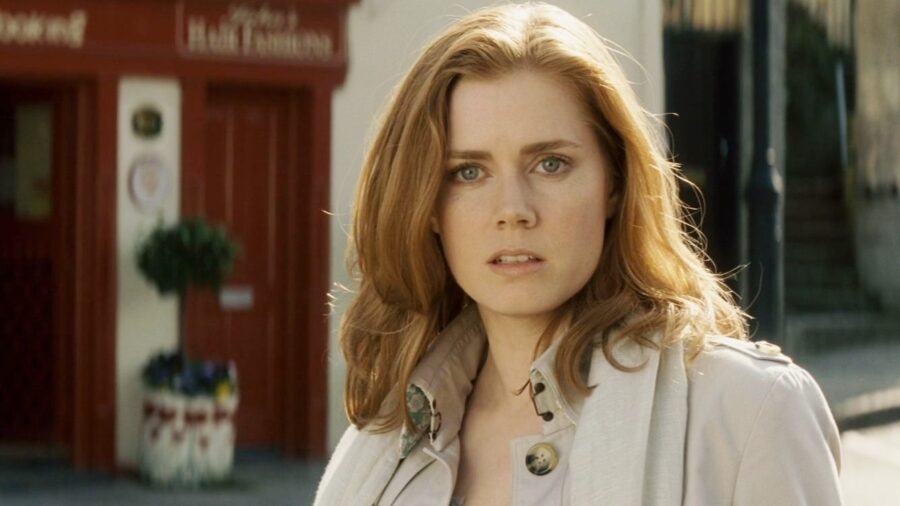Can you tell me more about the setting of this picture? The setting of this picture seems to be an urban street with a quaint, small business atmosphere. The red storefront in the background, adorned with a lush green plant in its window, suggests a vibrant and welcoming commercial area. The soft, natural light implies it could be early morning or late afternoon, giving the scene a peaceful and contemplative ambiance. What might she be thinking about in this picture? Her expression suggests she might be lost in deep thought or contemplation. Perhaps she's reflecting on a personal matter, considering an important decision, or reminiscing about a cherished memory. The serious and thoughtful look on her face hints at an introspective moment amid the hustle and bustle of the city street. 